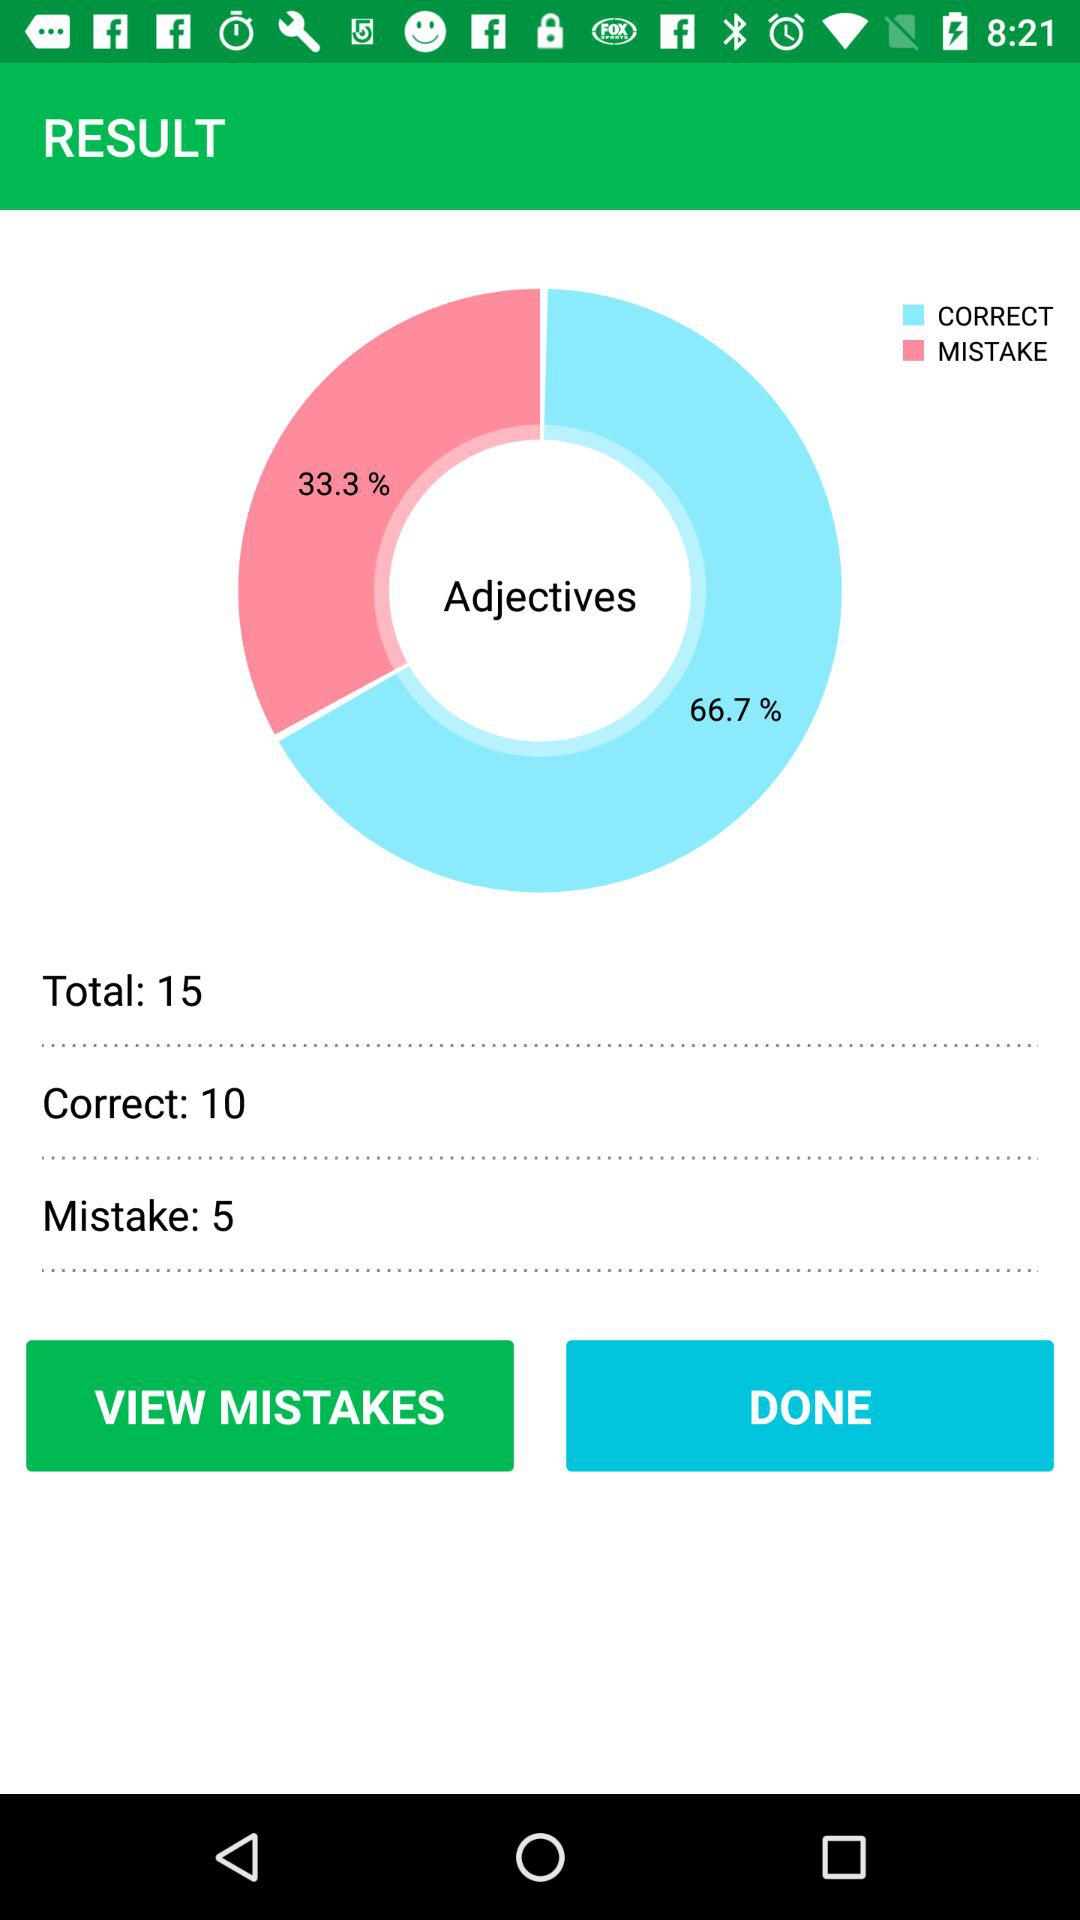What is the percentage of mistakes of adjectives? The percentage of mistakes of adjectives is 33.33. 